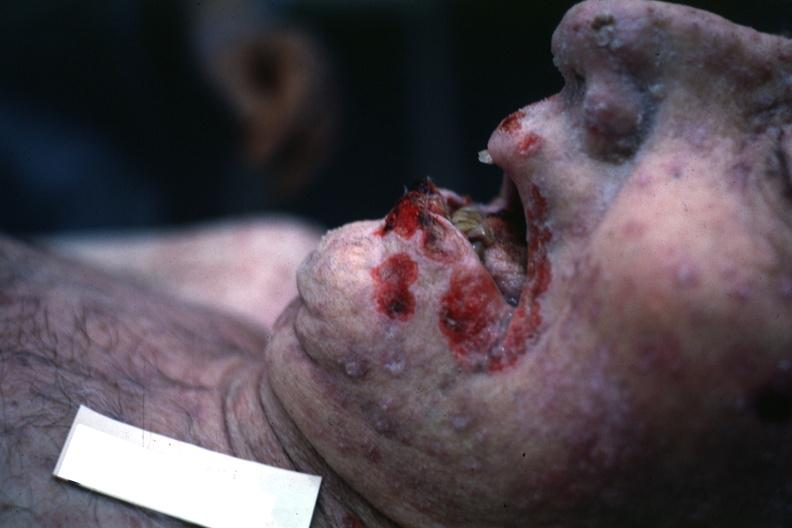does this image show good but grotesque?
Answer the question using a single word or phrase. Yes 